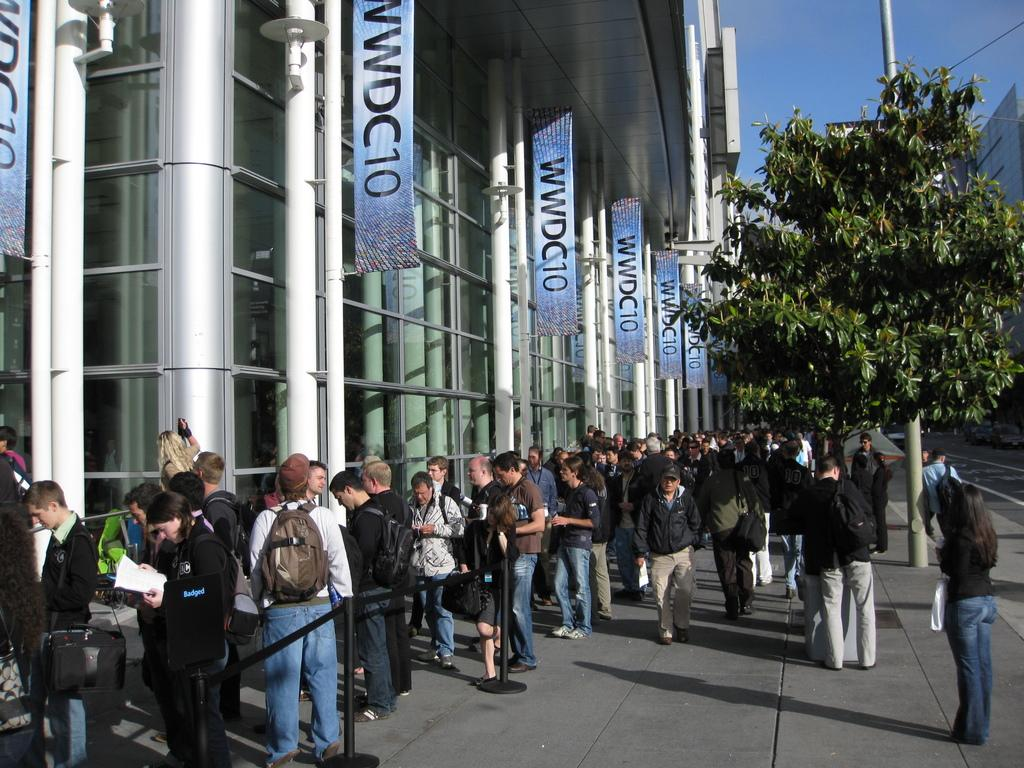<image>
Offer a succinct explanation of the picture presented. People line up under a series of banners reading WWDC10. 